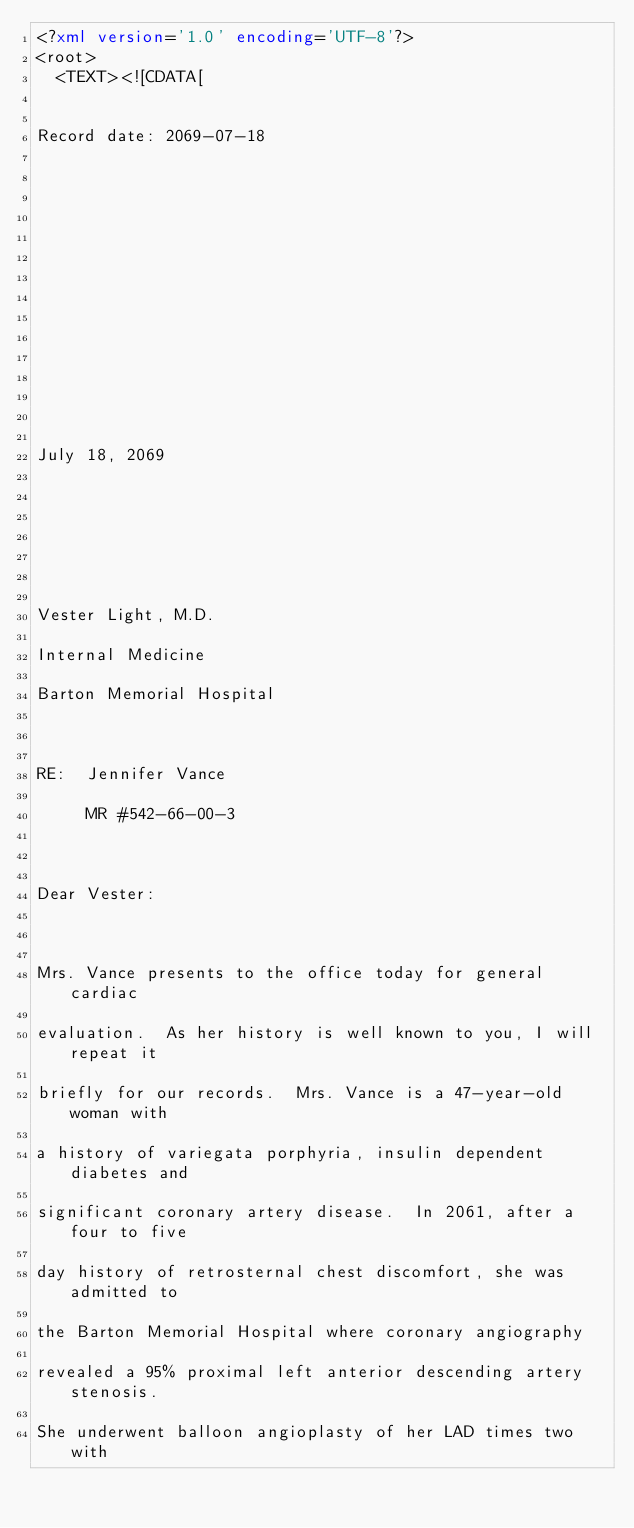<code> <loc_0><loc_0><loc_500><loc_500><_XML_><?xml version='1.0' encoding='UTF-8'?>
<root>
  <TEXT><![CDATA[


Record date: 2069-07-18

 

 

 

 

 

 

 

July 18, 2069

 

 

 

Vester Light, M.D.

Internal Medicine

Barton Memorial Hospital

 

RE:  Jennifer Vance

     MR #542-66-00-3

 

Dear Vester:

 

Mrs. Vance presents to the office today for general cardiac

evaluation.  As her history is well known to you, I will repeat it

briefly for our records.  Mrs. Vance is a 47-year-old woman with

a history of variegata porphyria, insulin dependent diabetes and

significant coronary artery disease.  In 2061, after a four to five

day history of retrosternal chest discomfort, she was admitted to

the Barton Memorial Hospital where coronary angiography

revealed a 95% proximal left anterior descending artery stenosis. 

She underwent balloon angioplasty of her LAD times two with
</code> 